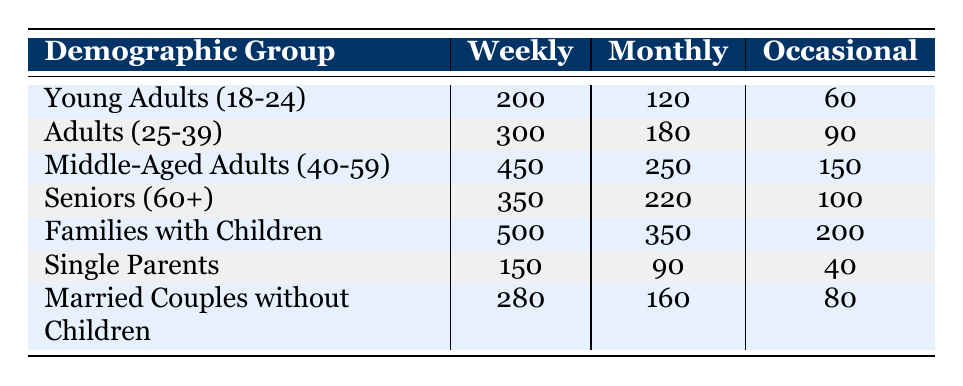What is the number of weekly attendees from Families with Children? From the table, under the "Families with Children" row, the value for "Weekly" attendance is directly listed as 500.
Answer: 500 Which demographic group has the lowest monthly attendance? The monthly attendance values are 120 for Young Adults, 180 for Adults, 250 for Middle-Aged Adults, 220 for Seniors, 350 for Families with Children, 90 for Single Parents, and 160 for Married Couples. The lowest value is 90, corresponding to "Single Parents."
Answer: Single Parents What is the total number of occasional attendees among all demographic groups? To find the total occasional attendance, add the occasional attendance values for all groups: 60 + 90 + 150 + 100 + 200 + 40 + 80 = 720.
Answer: 720 Is the weekly attendance of Middle-Aged Adults greater than the combined weekly attendance of Young Adults and Single Parents? First, find the weekly attendance of Middle-Aged Adults, which is 450. Then, calculate the combined attendance of Young Adults (200) and Single Parents (150): 200 + 150 = 350. Since 450 is greater than 350, the statement is true.
Answer: Yes What is the average monthly attendance across all demographic groups? To find the average monthly attendance, sum the monthly attendance values: 120 + 180 + 250 + 220 + 350 + 90 + 160 = 1,370. Then divide by the number of groups, which is 7: 1,370 / 7 = 195.71 (approximately 196).
Answer: 196 